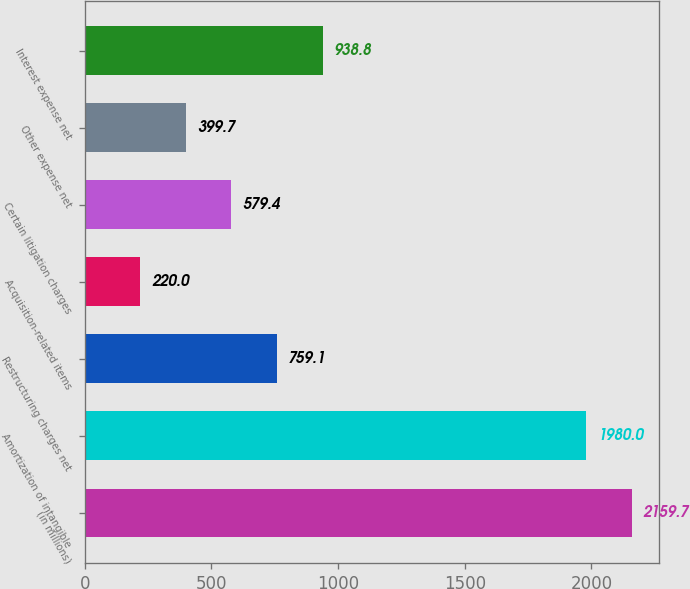<chart> <loc_0><loc_0><loc_500><loc_500><bar_chart><fcel>(in millions)<fcel>Amortization of intangible<fcel>Restructuring charges net<fcel>Acquisition-related items<fcel>Certain litigation charges<fcel>Other expense net<fcel>Interest expense net<nl><fcel>2159.7<fcel>1980<fcel>759.1<fcel>220<fcel>579.4<fcel>399.7<fcel>938.8<nl></chart> 